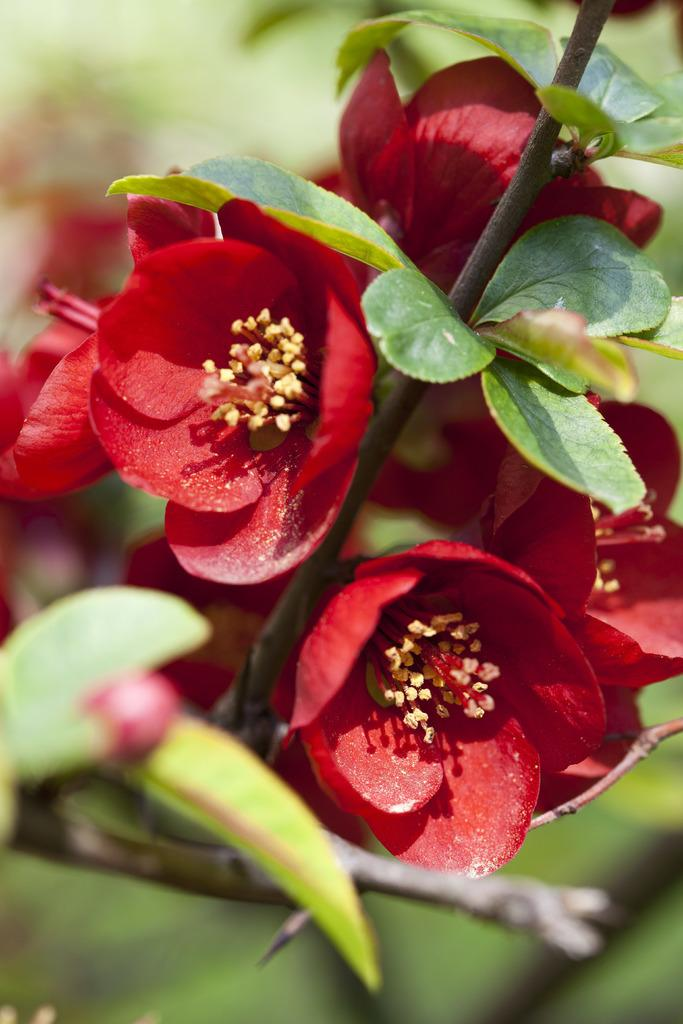What type of vegetation is visible in the front of the image? There are flowers in the front of the image. What other plant-related elements can be seen in the image? There are leaves in the image. How would you describe the background of the image? The background of the image is blurry. Can you see a stream flowing through the image? There is no stream visible in the image. How many teeth can be seen in the image? There are no teeth present in the image. 